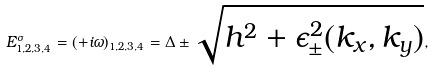<formula> <loc_0><loc_0><loc_500><loc_500>E ^ { \sigma } _ { 1 , 2 , 3 , 4 } = ( + i \omega ) _ { 1 , 2 , 3 , 4 } = \Delta \pm \sqrt { h ^ { 2 } + \epsilon ^ { 2 } _ { \pm } ( k _ { x } , k _ { y } ) } ,</formula> 